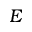Convert formula to latex. <formula><loc_0><loc_0><loc_500><loc_500>E</formula> 